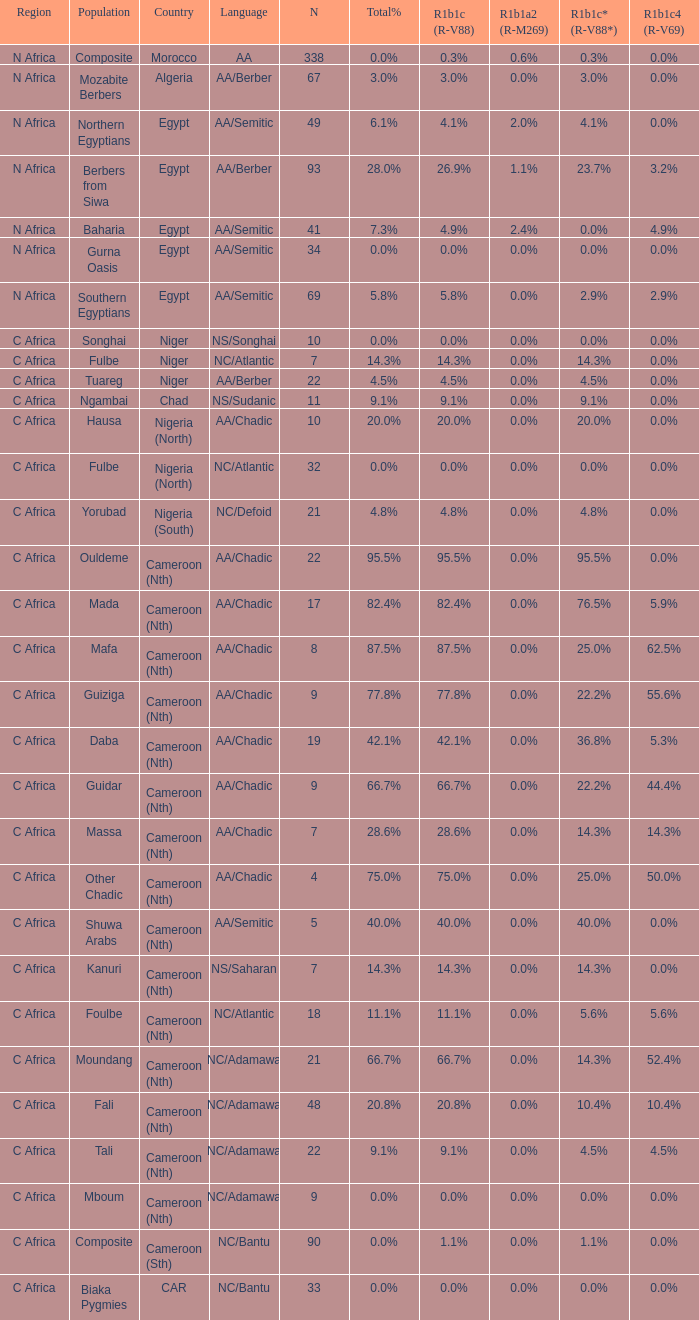Which languages are spoken in niger with r1b1c (r-v88) at NS/Songhai. 